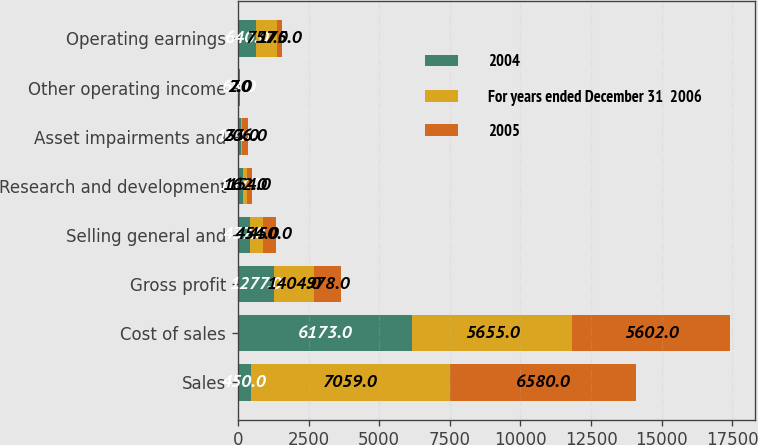<chart> <loc_0><loc_0><loc_500><loc_500><stacked_bar_chart><ecel><fcel>Sales<fcel>Cost of sales<fcel>Gross profit<fcel>Selling general and<fcel>Research and development<fcel>Asset impairments and<fcel>Other operating income<fcel>Operating earnings<nl><fcel>2004<fcel>450<fcel>6173<fcel>1277<fcel>437<fcel>167<fcel>101<fcel>68<fcel>640<nl><fcel>For years ended December 31  2006<fcel>7059<fcel>5655<fcel>1404<fcel>454<fcel>162<fcel>33<fcel>2<fcel>757<nl><fcel>2005<fcel>6580<fcel>5602<fcel>978<fcel>450<fcel>154<fcel>206<fcel>7<fcel>175<nl></chart> 